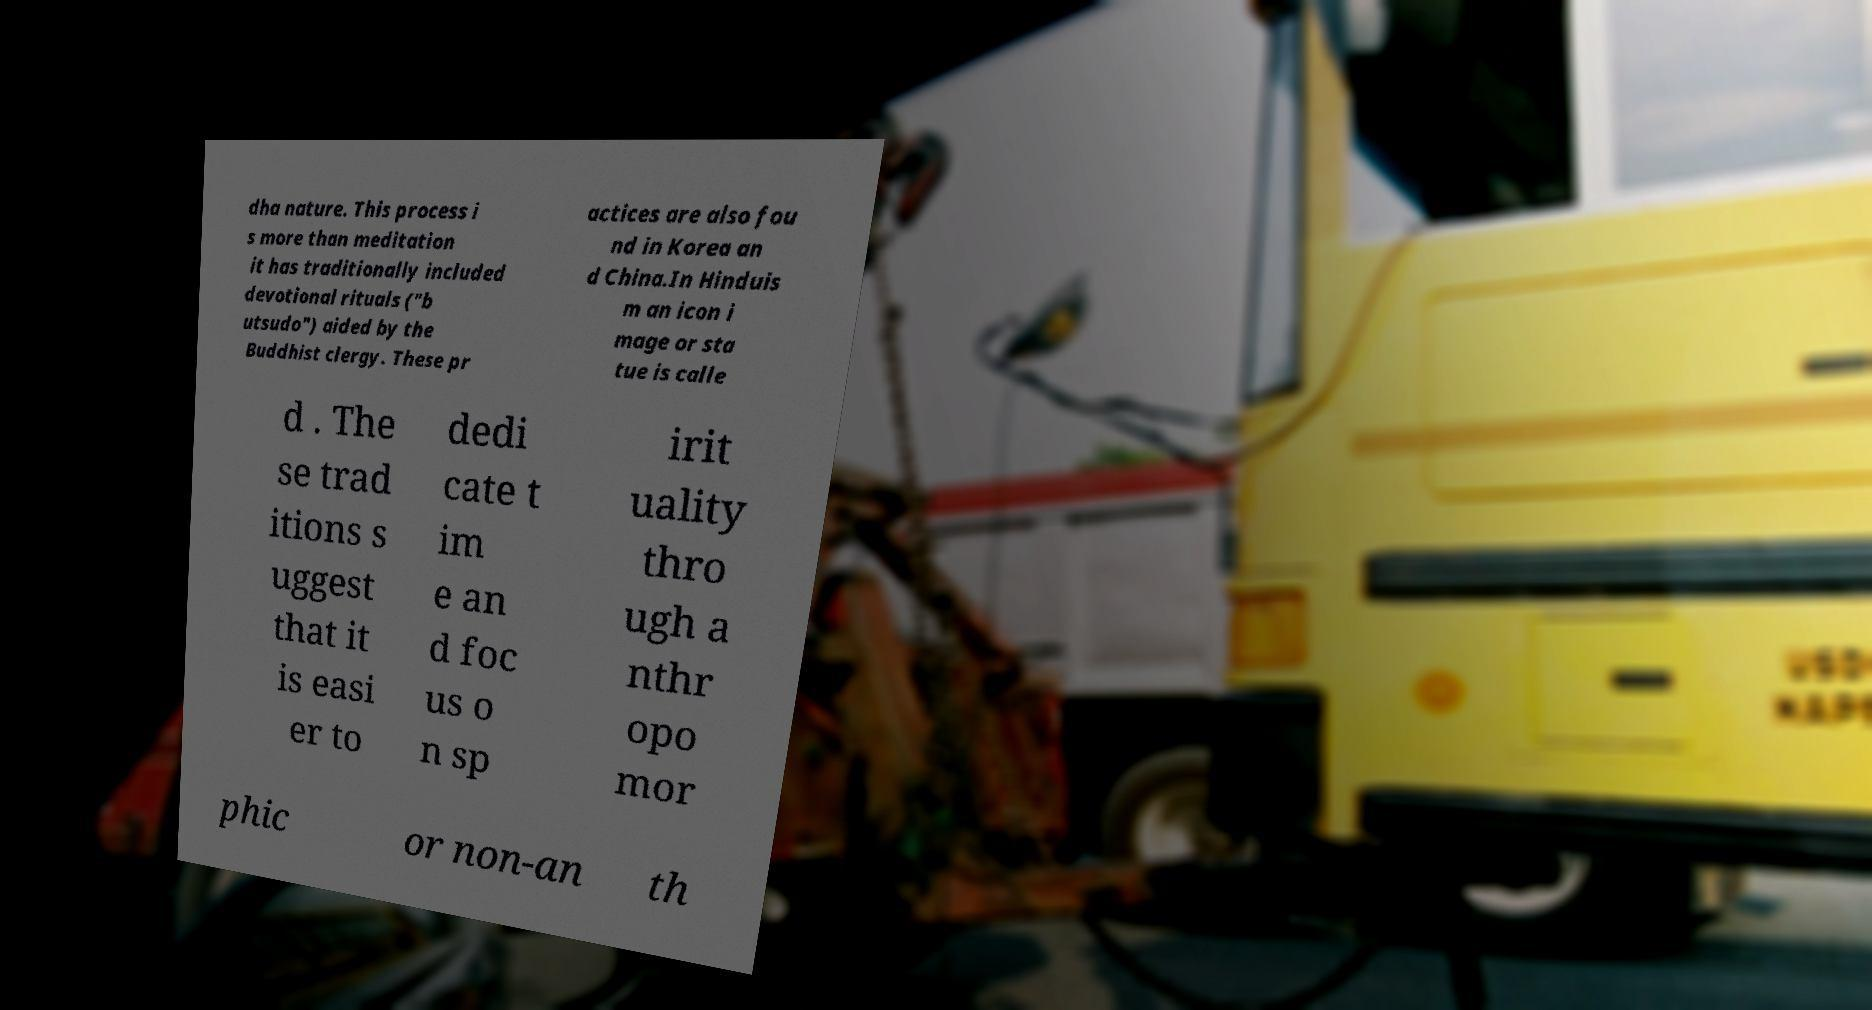Could you extract and type out the text from this image? dha nature. This process i s more than meditation it has traditionally included devotional rituals ("b utsudo") aided by the Buddhist clergy. These pr actices are also fou nd in Korea an d China.In Hinduis m an icon i mage or sta tue is calle d . The se trad itions s uggest that it is easi er to dedi cate t im e an d foc us o n sp irit uality thro ugh a nthr opo mor phic or non-an th 